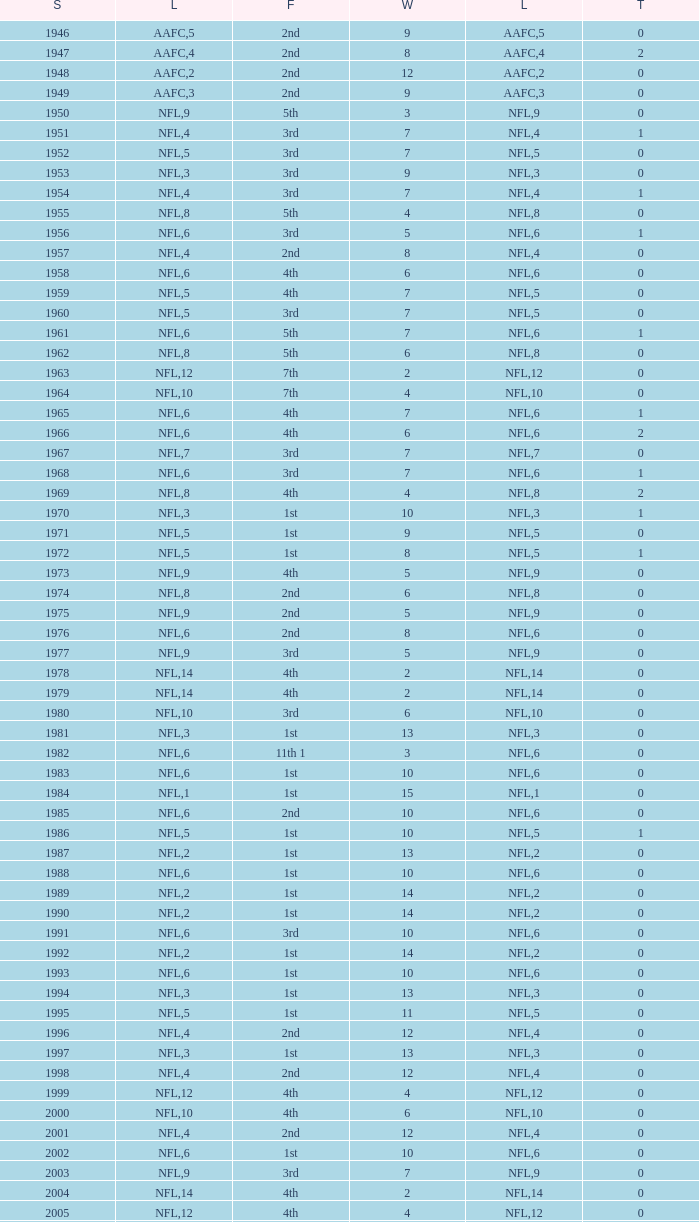What is the number of losses when the ties are lesser than 0? 0.0. 